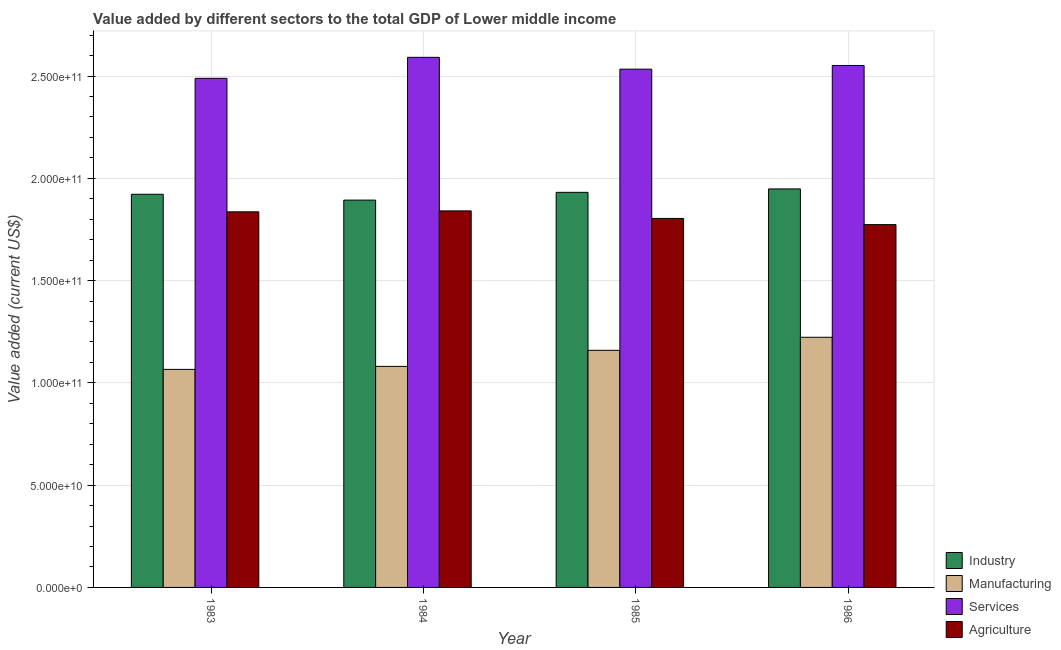How many different coloured bars are there?
Make the answer very short. 4. How many groups of bars are there?
Provide a short and direct response. 4. Are the number of bars on each tick of the X-axis equal?
Keep it short and to the point. Yes. How many bars are there on the 4th tick from the left?
Offer a terse response. 4. In how many cases, is the number of bars for a given year not equal to the number of legend labels?
Offer a very short reply. 0. What is the value added by industrial sector in 1985?
Your answer should be very brief. 1.93e+11. Across all years, what is the maximum value added by industrial sector?
Provide a short and direct response. 1.95e+11. Across all years, what is the minimum value added by manufacturing sector?
Keep it short and to the point. 1.07e+11. In which year was the value added by agricultural sector maximum?
Your response must be concise. 1984. What is the total value added by services sector in the graph?
Make the answer very short. 1.02e+12. What is the difference between the value added by agricultural sector in 1983 and that in 1985?
Provide a succinct answer. 3.23e+09. What is the difference between the value added by industrial sector in 1985 and the value added by agricultural sector in 1986?
Make the answer very short. -1.68e+09. What is the average value added by services sector per year?
Your answer should be very brief. 2.54e+11. In the year 1985, what is the difference between the value added by industrial sector and value added by manufacturing sector?
Give a very brief answer. 0. In how many years, is the value added by industrial sector greater than 120000000000 US$?
Provide a succinct answer. 4. What is the ratio of the value added by services sector in 1984 to that in 1986?
Ensure brevity in your answer.  1.02. Is the difference between the value added by industrial sector in 1984 and 1986 greater than the difference between the value added by manufacturing sector in 1984 and 1986?
Your response must be concise. No. What is the difference between the highest and the second highest value added by services sector?
Make the answer very short. 3.98e+09. What is the difference between the highest and the lowest value added by manufacturing sector?
Keep it short and to the point. 1.57e+1. What does the 3rd bar from the left in 1986 represents?
Give a very brief answer. Services. What does the 4th bar from the right in 1984 represents?
Your response must be concise. Industry. Is it the case that in every year, the sum of the value added by industrial sector and value added by manufacturing sector is greater than the value added by services sector?
Ensure brevity in your answer.  Yes. Are all the bars in the graph horizontal?
Make the answer very short. No. How many years are there in the graph?
Offer a terse response. 4. What is the difference between two consecutive major ticks on the Y-axis?
Give a very brief answer. 5.00e+1. Are the values on the major ticks of Y-axis written in scientific E-notation?
Provide a short and direct response. Yes. Does the graph contain any zero values?
Offer a terse response. No. Does the graph contain grids?
Provide a short and direct response. Yes. Where does the legend appear in the graph?
Provide a succinct answer. Bottom right. How many legend labels are there?
Give a very brief answer. 4. What is the title of the graph?
Offer a very short reply. Value added by different sectors to the total GDP of Lower middle income. What is the label or title of the X-axis?
Provide a succinct answer. Year. What is the label or title of the Y-axis?
Keep it short and to the point. Value added (current US$). What is the Value added (current US$) in Industry in 1983?
Keep it short and to the point. 1.92e+11. What is the Value added (current US$) of Manufacturing in 1983?
Your answer should be very brief. 1.07e+11. What is the Value added (current US$) of Services in 1983?
Make the answer very short. 2.49e+11. What is the Value added (current US$) of Agriculture in 1983?
Ensure brevity in your answer.  1.84e+11. What is the Value added (current US$) of Industry in 1984?
Provide a short and direct response. 1.89e+11. What is the Value added (current US$) of Manufacturing in 1984?
Keep it short and to the point. 1.08e+11. What is the Value added (current US$) in Services in 1984?
Give a very brief answer. 2.59e+11. What is the Value added (current US$) of Agriculture in 1984?
Provide a succinct answer. 1.84e+11. What is the Value added (current US$) in Industry in 1985?
Give a very brief answer. 1.93e+11. What is the Value added (current US$) in Manufacturing in 1985?
Give a very brief answer. 1.16e+11. What is the Value added (current US$) of Services in 1985?
Offer a terse response. 2.53e+11. What is the Value added (current US$) in Agriculture in 1985?
Give a very brief answer. 1.80e+11. What is the Value added (current US$) of Industry in 1986?
Keep it short and to the point. 1.95e+11. What is the Value added (current US$) in Manufacturing in 1986?
Your response must be concise. 1.22e+11. What is the Value added (current US$) of Services in 1986?
Your answer should be very brief. 2.55e+11. What is the Value added (current US$) of Agriculture in 1986?
Provide a succinct answer. 1.77e+11. Across all years, what is the maximum Value added (current US$) in Industry?
Your answer should be very brief. 1.95e+11. Across all years, what is the maximum Value added (current US$) of Manufacturing?
Provide a short and direct response. 1.22e+11. Across all years, what is the maximum Value added (current US$) in Services?
Make the answer very short. 2.59e+11. Across all years, what is the maximum Value added (current US$) in Agriculture?
Ensure brevity in your answer.  1.84e+11. Across all years, what is the minimum Value added (current US$) of Industry?
Offer a very short reply. 1.89e+11. Across all years, what is the minimum Value added (current US$) of Manufacturing?
Ensure brevity in your answer.  1.07e+11. Across all years, what is the minimum Value added (current US$) of Services?
Your response must be concise. 2.49e+11. Across all years, what is the minimum Value added (current US$) of Agriculture?
Your answer should be very brief. 1.77e+11. What is the total Value added (current US$) in Industry in the graph?
Provide a succinct answer. 7.70e+11. What is the total Value added (current US$) in Manufacturing in the graph?
Provide a short and direct response. 4.53e+11. What is the total Value added (current US$) of Services in the graph?
Keep it short and to the point. 1.02e+12. What is the total Value added (current US$) of Agriculture in the graph?
Keep it short and to the point. 7.25e+11. What is the difference between the Value added (current US$) of Industry in 1983 and that in 1984?
Offer a terse response. 2.85e+09. What is the difference between the Value added (current US$) of Manufacturing in 1983 and that in 1984?
Provide a short and direct response. -1.47e+09. What is the difference between the Value added (current US$) in Services in 1983 and that in 1984?
Your answer should be compact. -1.03e+1. What is the difference between the Value added (current US$) of Agriculture in 1983 and that in 1984?
Offer a very short reply. -4.63e+08. What is the difference between the Value added (current US$) of Industry in 1983 and that in 1985?
Offer a terse response. -9.46e+08. What is the difference between the Value added (current US$) of Manufacturing in 1983 and that in 1985?
Your response must be concise. -9.32e+09. What is the difference between the Value added (current US$) of Services in 1983 and that in 1985?
Make the answer very short. -4.48e+09. What is the difference between the Value added (current US$) of Agriculture in 1983 and that in 1985?
Give a very brief answer. 3.23e+09. What is the difference between the Value added (current US$) in Industry in 1983 and that in 1986?
Keep it short and to the point. -2.62e+09. What is the difference between the Value added (current US$) in Manufacturing in 1983 and that in 1986?
Offer a terse response. -1.57e+1. What is the difference between the Value added (current US$) in Services in 1983 and that in 1986?
Your answer should be compact. -6.28e+09. What is the difference between the Value added (current US$) in Agriculture in 1983 and that in 1986?
Make the answer very short. 6.24e+09. What is the difference between the Value added (current US$) in Industry in 1984 and that in 1985?
Offer a very short reply. -3.80e+09. What is the difference between the Value added (current US$) of Manufacturing in 1984 and that in 1985?
Offer a very short reply. -7.85e+09. What is the difference between the Value added (current US$) in Services in 1984 and that in 1985?
Keep it short and to the point. 5.79e+09. What is the difference between the Value added (current US$) of Agriculture in 1984 and that in 1985?
Ensure brevity in your answer.  3.69e+09. What is the difference between the Value added (current US$) in Industry in 1984 and that in 1986?
Your answer should be compact. -5.47e+09. What is the difference between the Value added (current US$) of Manufacturing in 1984 and that in 1986?
Ensure brevity in your answer.  -1.42e+1. What is the difference between the Value added (current US$) in Services in 1984 and that in 1986?
Ensure brevity in your answer.  3.98e+09. What is the difference between the Value added (current US$) in Agriculture in 1984 and that in 1986?
Your answer should be very brief. 6.71e+09. What is the difference between the Value added (current US$) of Industry in 1985 and that in 1986?
Offer a very short reply. -1.68e+09. What is the difference between the Value added (current US$) of Manufacturing in 1985 and that in 1986?
Make the answer very short. -6.38e+09. What is the difference between the Value added (current US$) of Services in 1985 and that in 1986?
Your response must be concise. -1.81e+09. What is the difference between the Value added (current US$) in Agriculture in 1985 and that in 1986?
Offer a very short reply. 3.01e+09. What is the difference between the Value added (current US$) in Industry in 1983 and the Value added (current US$) in Manufacturing in 1984?
Offer a terse response. 8.41e+1. What is the difference between the Value added (current US$) in Industry in 1983 and the Value added (current US$) in Services in 1984?
Your answer should be very brief. -6.70e+1. What is the difference between the Value added (current US$) of Industry in 1983 and the Value added (current US$) of Agriculture in 1984?
Keep it short and to the point. 8.13e+09. What is the difference between the Value added (current US$) of Manufacturing in 1983 and the Value added (current US$) of Services in 1984?
Keep it short and to the point. -1.53e+11. What is the difference between the Value added (current US$) in Manufacturing in 1983 and the Value added (current US$) in Agriculture in 1984?
Your answer should be compact. -7.75e+1. What is the difference between the Value added (current US$) of Services in 1983 and the Value added (current US$) of Agriculture in 1984?
Ensure brevity in your answer.  6.48e+1. What is the difference between the Value added (current US$) of Industry in 1983 and the Value added (current US$) of Manufacturing in 1985?
Your response must be concise. 7.63e+1. What is the difference between the Value added (current US$) of Industry in 1983 and the Value added (current US$) of Services in 1985?
Your answer should be compact. -6.12e+1. What is the difference between the Value added (current US$) of Industry in 1983 and the Value added (current US$) of Agriculture in 1985?
Your answer should be very brief. 1.18e+1. What is the difference between the Value added (current US$) in Manufacturing in 1983 and the Value added (current US$) in Services in 1985?
Keep it short and to the point. -1.47e+11. What is the difference between the Value added (current US$) of Manufacturing in 1983 and the Value added (current US$) of Agriculture in 1985?
Give a very brief answer. -7.38e+1. What is the difference between the Value added (current US$) of Services in 1983 and the Value added (current US$) of Agriculture in 1985?
Your response must be concise. 6.85e+1. What is the difference between the Value added (current US$) in Industry in 1983 and the Value added (current US$) in Manufacturing in 1986?
Your answer should be very brief. 6.99e+1. What is the difference between the Value added (current US$) of Industry in 1983 and the Value added (current US$) of Services in 1986?
Your answer should be compact. -6.30e+1. What is the difference between the Value added (current US$) in Industry in 1983 and the Value added (current US$) in Agriculture in 1986?
Your answer should be very brief. 1.48e+1. What is the difference between the Value added (current US$) in Manufacturing in 1983 and the Value added (current US$) in Services in 1986?
Your answer should be compact. -1.49e+11. What is the difference between the Value added (current US$) of Manufacturing in 1983 and the Value added (current US$) of Agriculture in 1986?
Keep it short and to the point. -7.08e+1. What is the difference between the Value added (current US$) in Services in 1983 and the Value added (current US$) in Agriculture in 1986?
Ensure brevity in your answer.  7.15e+1. What is the difference between the Value added (current US$) of Industry in 1984 and the Value added (current US$) of Manufacturing in 1985?
Ensure brevity in your answer.  7.34e+1. What is the difference between the Value added (current US$) in Industry in 1984 and the Value added (current US$) in Services in 1985?
Your answer should be very brief. -6.40e+1. What is the difference between the Value added (current US$) in Industry in 1984 and the Value added (current US$) in Agriculture in 1985?
Offer a very short reply. 8.97e+09. What is the difference between the Value added (current US$) of Manufacturing in 1984 and the Value added (current US$) of Services in 1985?
Offer a terse response. -1.45e+11. What is the difference between the Value added (current US$) in Manufacturing in 1984 and the Value added (current US$) in Agriculture in 1985?
Offer a very short reply. -7.23e+1. What is the difference between the Value added (current US$) in Services in 1984 and the Value added (current US$) in Agriculture in 1985?
Keep it short and to the point. 7.88e+1. What is the difference between the Value added (current US$) in Industry in 1984 and the Value added (current US$) in Manufacturing in 1986?
Give a very brief answer. 6.71e+1. What is the difference between the Value added (current US$) of Industry in 1984 and the Value added (current US$) of Services in 1986?
Your response must be concise. -6.58e+1. What is the difference between the Value added (current US$) of Industry in 1984 and the Value added (current US$) of Agriculture in 1986?
Provide a succinct answer. 1.20e+1. What is the difference between the Value added (current US$) of Manufacturing in 1984 and the Value added (current US$) of Services in 1986?
Your answer should be very brief. -1.47e+11. What is the difference between the Value added (current US$) of Manufacturing in 1984 and the Value added (current US$) of Agriculture in 1986?
Offer a very short reply. -6.93e+1. What is the difference between the Value added (current US$) in Services in 1984 and the Value added (current US$) in Agriculture in 1986?
Keep it short and to the point. 8.18e+1. What is the difference between the Value added (current US$) of Industry in 1985 and the Value added (current US$) of Manufacturing in 1986?
Offer a terse response. 7.09e+1. What is the difference between the Value added (current US$) of Industry in 1985 and the Value added (current US$) of Services in 1986?
Give a very brief answer. -6.20e+1. What is the difference between the Value added (current US$) of Industry in 1985 and the Value added (current US$) of Agriculture in 1986?
Provide a short and direct response. 1.58e+1. What is the difference between the Value added (current US$) of Manufacturing in 1985 and the Value added (current US$) of Services in 1986?
Your answer should be very brief. -1.39e+11. What is the difference between the Value added (current US$) in Manufacturing in 1985 and the Value added (current US$) in Agriculture in 1986?
Give a very brief answer. -6.15e+1. What is the difference between the Value added (current US$) of Services in 1985 and the Value added (current US$) of Agriculture in 1986?
Your answer should be very brief. 7.60e+1. What is the average Value added (current US$) of Industry per year?
Make the answer very short. 1.92e+11. What is the average Value added (current US$) in Manufacturing per year?
Your answer should be very brief. 1.13e+11. What is the average Value added (current US$) of Services per year?
Offer a very short reply. 2.54e+11. What is the average Value added (current US$) of Agriculture per year?
Provide a succinct answer. 1.81e+11. In the year 1983, what is the difference between the Value added (current US$) of Industry and Value added (current US$) of Manufacturing?
Give a very brief answer. 8.56e+1. In the year 1983, what is the difference between the Value added (current US$) in Industry and Value added (current US$) in Services?
Offer a terse response. -5.67e+1. In the year 1983, what is the difference between the Value added (current US$) in Industry and Value added (current US$) in Agriculture?
Keep it short and to the point. 8.59e+09. In the year 1983, what is the difference between the Value added (current US$) in Manufacturing and Value added (current US$) in Services?
Keep it short and to the point. -1.42e+11. In the year 1983, what is the difference between the Value added (current US$) of Manufacturing and Value added (current US$) of Agriculture?
Provide a succinct answer. -7.70e+1. In the year 1983, what is the difference between the Value added (current US$) of Services and Value added (current US$) of Agriculture?
Give a very brief answer. 6.53e+1. In the year 1984, what is the difference between the Value added (current US$) of Industry and Value added (current US$) of Manufacturing?
Ensure brevity in your answer.  8.13e+1. In the year 1984, what is the difference between the Value added (current US$) of Industry and Value added (current US$) of Services?
Provide a short and direct response. -6.98e+1. In the year 1984, what is the difference between the Value added (current US$) of Industry and Value added (current US$) of Agriculture?
Your answer should be compact. 5.28e+09. In the year 1984, what is the difference between the Value added (current US$) in Manufacturing and Value added (current US$) in Services?
Keep it short and to the point. -1.51e+11. In the year 1984, what is the difference between the Value added (current US$) of Manufacturing and Value added (current US$) of Agriculture?
Provide a succinct answer. -7.60e+1. In the year 1984, what is the difference between the Value added (current US$) of Services and Value added (current US$) of Agriculture?
Offer a very short reply. 7.51e+1. In the year 1985, what is the difference between the Value added (current US$) in Industry and Value added (current US$) in Manufacturing?
Ensure brevity in your answer.  7.72e+1. In the year 1985, what is the difference between the Value added (current US$) in Industry and Value added (current US$) in Services?
Your response must be concise. -6.02e+1. In the year 1985, what is the difference between the Value added (current US$) of Industry and Value added (current US$) of Agriculture?
Your answer should be compact. 1.28e+1. In the year 1985, what is the difference between the Value added (current US$) of Manufacturing and Value added (current US$) of Services?
Your answer should be compact. -1.37e+11. In the year 1985, what is the difference between the Value added (current US$) in Manufacturing and Value added (current US$) in Agriculture?
Your answer should be compact. -6.45e+1. In the year 1985, what is the difference between the Value added (current US$) in Services and Value added (current US$) in Agriculture?
Offer a terse response. 7.30e+1. In the year 1986, what is the difference between the Value added (current US$) of Industry and Value added (current US$) of Manufacturing?
Make the answer very short. 7.25e+1. In the year 1986, what is the difference between the Value added (current US$) of Industry and Value added (current US$) of Services?
Keep it short and to the point. -6.03e+1. In the year 1986, what is the difference between the Value added (current US$) in Industry and Value added (current US$) in Agriculture?
Make the answer very short. 1.75e+1. In the year 1986, what is the difference between the Value added (current US$) of Manufacturing and Value added (current US$) of Services?
Make the answer very short. -1.33e+11. In the year 1986, what is the difference between the Value added (current US$) of Manufacturing and Value added (current US$) of Agriculture?
Give a very brief answer. -5.51e+1. In the year 1986, what is the difference between the Value added (current US$) in Services and Value added (current US$) in Agriculture?
Keep it short and to the point. 7.78e+1. What is the ratio of the Value added (current US$) in Manufacturing in 1983 to that in 1984?
Provide a succinct answer. 0.99. What is the ratio of the Value added (current US$) of Services in 1983 to that in 1984?
Your answer should be very brief. 0.96. What is the ratio of the Value added (current US$) in Agriculture in 1983 to that in 1984?
Give a very brief answer. 1. What is the ratio of the Value added (current US$) in Manufacturing in 1983 to that in 1985?
Give a very brief answer. 0.92. What is the ratio of the Value added (current US$) of Services in 1983 to that in 1985?
Keep it short and to the point. 0.98. What is the ratio of the Value added (current US$) of Agriculture in 1983 to that in 1985?
Provide a short and direct response. 1.02. What is the ratio of the Value added (current US$) in Industry in 1983 to that in 1986?
Offer a very short reply. 0.99. What is the ratio of the Value added (current US$) of Manufacturing in 1983 to that in 1986?
Provide a succinct answer. 0.87. What is the ratio of the Value added (current US$) in Services in 1983 to that in 1986?
Your answer should be very brief. 0.98. What is the ratio of the Value added (current US$) in Agriculture in 1983 to that in 1986?
Your answer should be very brief. 1.04. What is the ratio of the Value added (current US$) of Industry in 1984 to that in 1985?
Offer a terse response. 0.98. What is the ratio of the Value added (current US$) in Manufacturing in 1984 to that in 1985?
Provide a succinct answer. 0.93. What is the ratio of the Value added (current US$) of Services in 1984 to that in 1985?
Give a very brief answer. 1.02. What is the ratio of the Value added (current US$) in Agriculture in 1984 to that in 1985?
Keep it short and to the point. 1.02. What is the ratio of the Value added (current US$) of Industry in 1984 to that in 1986?
Your response must be concise. 0.97. What is the ratio of the Value added (current US$) in Manufacturing in 1984 to that in 1986?
Your answer should be compact. 0.88. What is the ratio of the Value added (current US$) in Services in 1984 to that in 1986?
Provide a short and direct response. 1.02. What is the ratio of the Value added (current US$) of Agriculture in 1984 to that in 1986?
Give a very brief answer. 1.04. What is the ratio of the Value added (current US$) in Manufacturing in 1985 to that in 1986?
Offer a terse response. 0.95. What is the ratio of the Value added (current US$) in Services in 1985 to that in 1986?
Provide a short and direct response. 0.99. What is the difference between the highest and the second highest Value added (current US$) of Industry?
Your response must be concise. 1.68e+09. What is the difference between the highest and the second highest Value added (current US$) of Manufacturing?
Ensure brevity in your answer.  6.38e+09. What is the difference between the highest and the second highest Value added (current US$) of Services?
Give a very brief answer. 3.98e+09. What is the difference between the highest and the second highest Value added (current US$) in Agriculture?
Provide a succinct answer. 4.63e+08. What is the difference between the highest and the lowest Value added (current US$) of Industry?
Your answer should be very brief. 5.47e+09. What is the difference between the highest and the lowest Value added (current US$) of Manufacturing?
Offer a very short reply. 1.57e+1. What is the difference between the highest and the lowest Value added (current US$) of Services?
Offer a very short reply. 1.03e+1. What is the difference between the highest and the lowest Value added (current US$) in Agriculture?
Your answer should be very brief. 6.71e+09. 